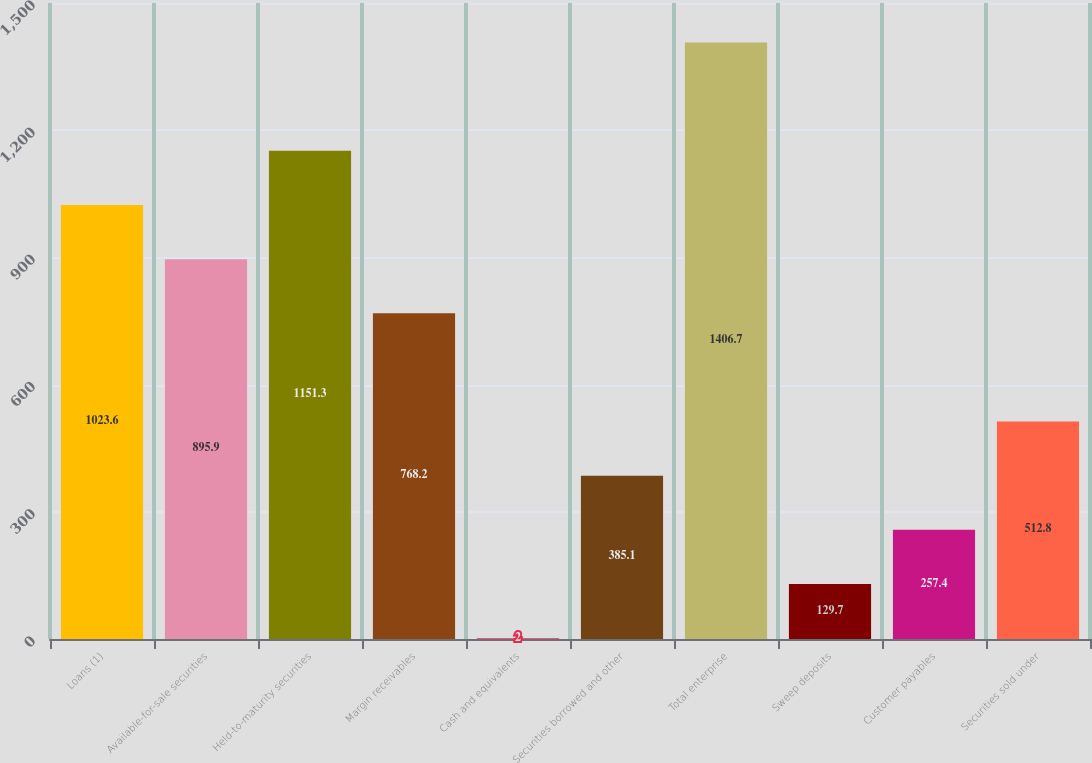<chart> <loc_0><loc_0><loc_500><loc_500><bar_chart><fcel>Loans (1)<fcel>Available-for-sale securities<fcel>Held-to-maturity securities<fcel>Margin receivables<fcel>Cash and equivalents<fcel>Securities borrowed and other<fcel>Total enterprise<fcel>Sweep deposits<fcel>Customer payables<fcel>Securities sold under<nl><fcel>1023.6<fcel>895.9<fcel>1151.3<fcel>768.2<fcel>2<fcel>385.1<fcel>1406.7<fcel>129.7<fcel>257.4<fcel>512.8<nl></chart> 